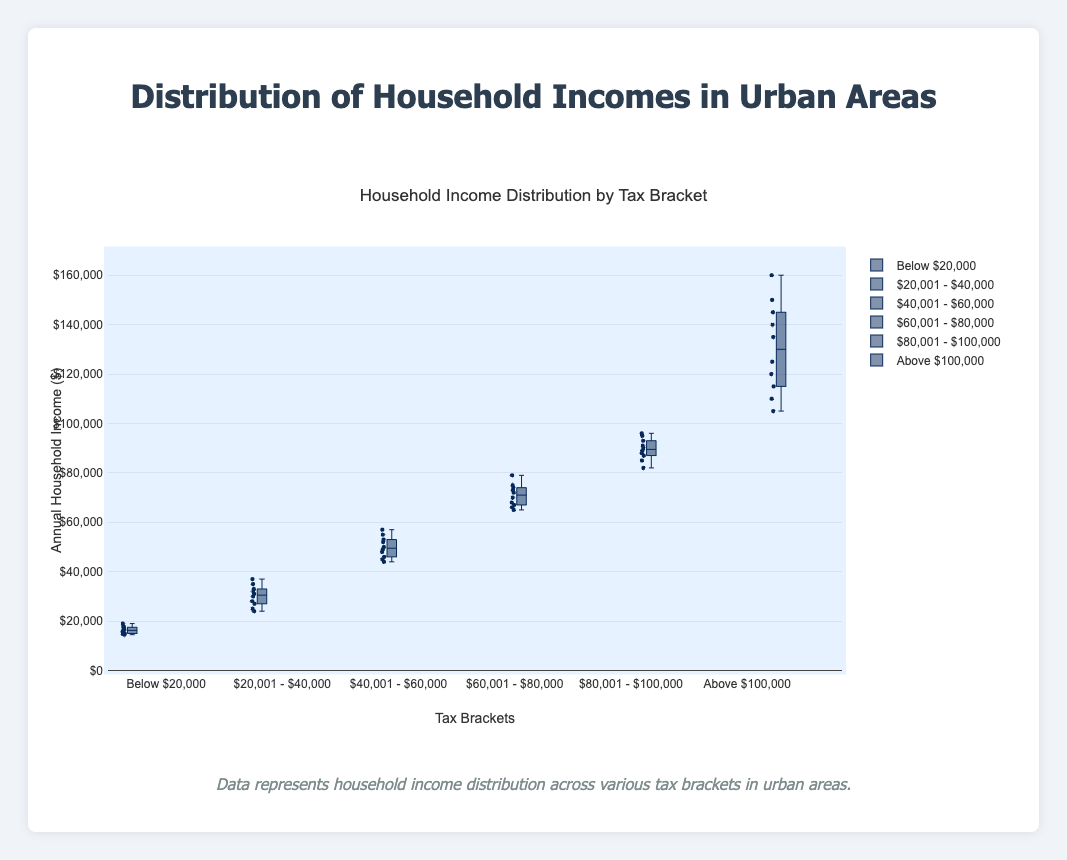What is the title of the figure? Look at the top of the figure to find the title.
Answer: Household Income Distribution by Tax Bracket How many tax brackets are displayed in the figure? Count the number of box plots or the distinct labels on the x-axis.
Answer: Six What is the range of the y-axis? Observe the values on the y-axis from the bottom to the top.
Answer: 0 to 170000 Which tax bracket has the highest median household income? Identify the middle line of the box and compare across all tax brackets to see which is the highest.
Answer: Above $100,000 What is the median household income for the "$40,001 - $60,000" tax bracket? Look at the middle line within the box for the "$40,001 - $60,000" bracket.
Answer: 49500 Which tax bracket has the broadest range of household incomes? Look at the length of the boxes and whiskers to determine which is the widest.
Answer: Above $100,000 How many household data points are there in the "Below $20,000" tax bracket? Count the individual points within the "Below $20,000" box plot.
Answer: 10 Which tax bracket has the lowest minimum household income? Locate the bottom whisker or the lowest point of each tax bracket and identify the smallest value.
Answer: Below $20,000 How does the median household income compare between the "$20,001 - $40,000" and "$80,001 - $100,000" tax brackets? Compare the median lines in the boxes for both tax brackets to see which is higher and by how much.
Answer: $80,001 - $100,000 has a higher median What is the interquartile range (IQR) for the "$60,001 - $80,000" tax bracket? Subtract the value at the lower quartile (bottom of the box) from the value at the upper quartile (top of the box) within the "$60,001 - $80,000" tax bracket.
Answer: 12500 